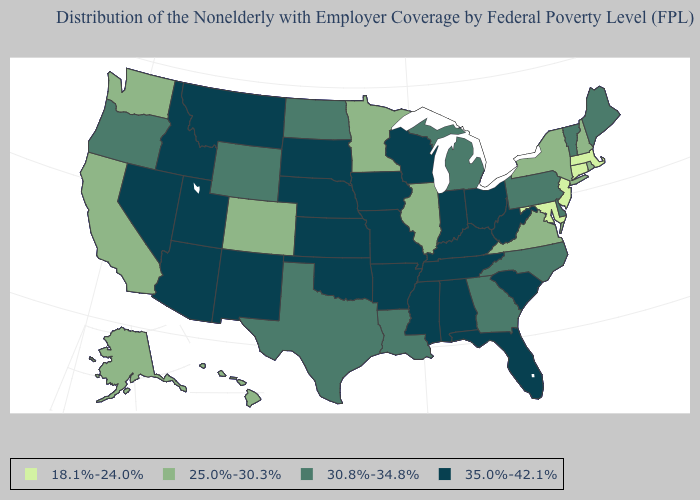What is the lowest value in the USA?
Be succinct. 18.1%-24.0%. Which states have the highest value in the USA?
Answer briefly. Alabama, Arizona, Arkansas, Florida, Idaho, Indiana, Iowa, Kansas, Kentucky, Mississippi, Missouri, Montana, Nebraska, Nevada, New Mexico, Ohio, Oklahoma, South Carolina, South Dakota, Tennessee, Utah, West Virginia, Wisconsin. Does California have the lowest value in the West?
Quick response, please. Yes. Name the states that have a value in the range 30.8%-34.8%?
Answer briefly. Delaware, Georgia, Louisiana, Maine, Michigan, North Carolina, North Dakota, Oregon, Pennsylvania, Texas, Vermont, Wyoming. Among the states that border North Carolina , which have the lowest value?
Answer briefly. Virginia. Does Massachusetts have the same value as Maryland?
Write a very short answer. Yes. Among the states that border Ohio , does Pennsylvania have the highest value?
Write a very short answer. No. Does Maine have the lowest value in the Northeast?
Answer briefly. No. Name the states that have a value in the range 35.0%-42.1%?
Keep it brief. Alabama, Arizona, Arkansas, Florida, Idaho, Indiana, Iowa, Kansas, Kentucky, Mississippi, Missouri, Montana, Nebraska, Nevada, New Mexico, Ohio, Oklahoma, South Carolina, South Dakota, Tennessee, Utah, West Virginia, Wisconsin. Does Connecticut have the lowest value in the Northeast?
Concise answer only. Yes. What is the value of Wyoming?
Concise answer only. 30.8%-34.8%. Does Georgia have the lowest value in the South?
Quick response, please. No. Is the legend a continuous bar?
Answer briefly. No. Among the states that border Rhode Island , which have the highest value?
Be succinct. Connecticut, Massachusetts. What is the highest value in the USA?
Keep it brief. 35.0%-42.1%. 